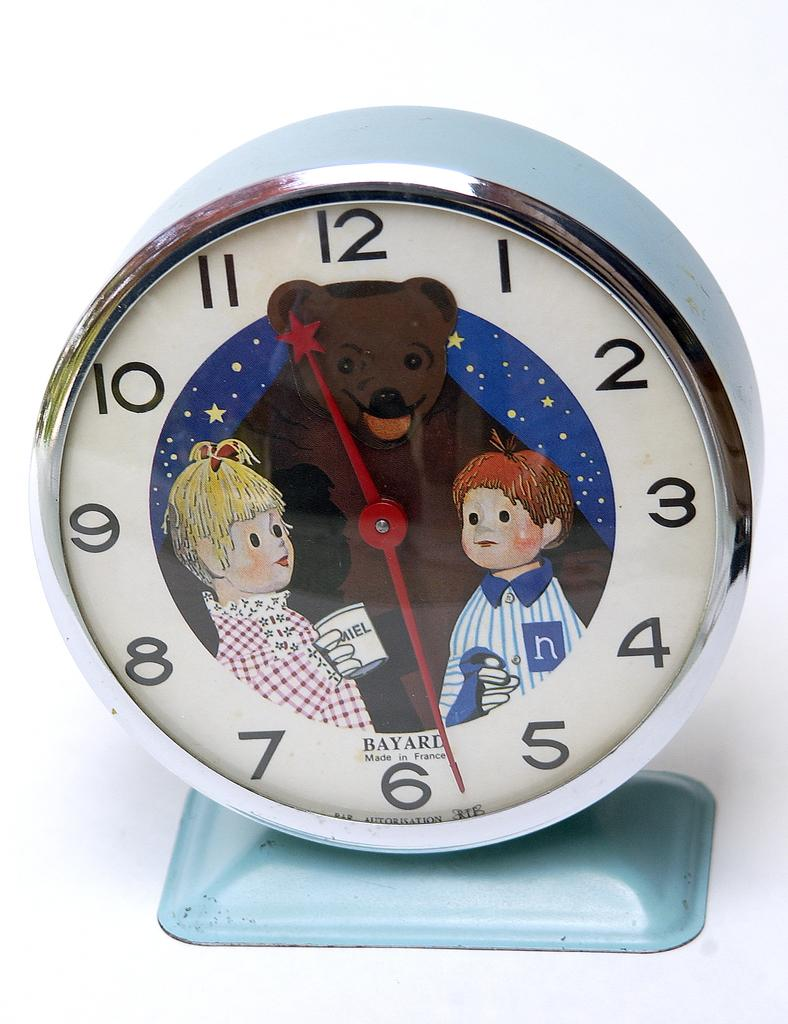<image>
Provide a brief description of the given image. A clock which was made in France has a drawing of a bear next to a boy and a girl. 